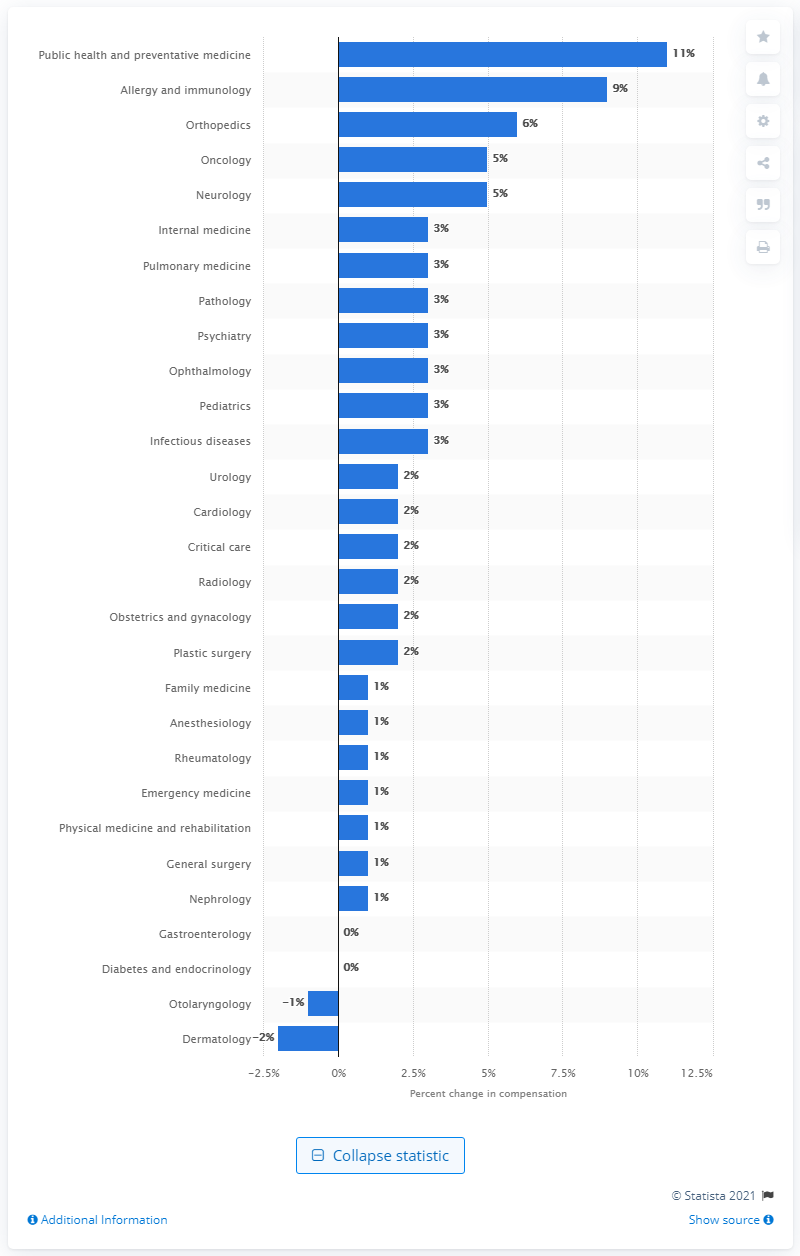Highlight a few significant elements in this photo. The specialty that saw the largest increase in salary between this year's and last year's compensation survey is public health and preventative medicine. 